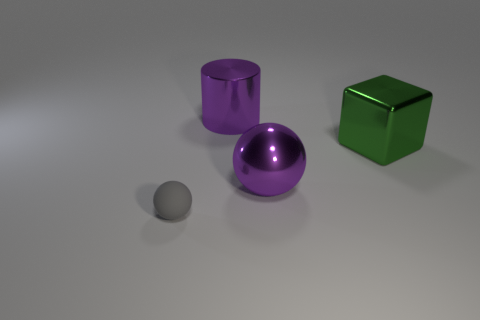Are there any other things that have the same material as the gray object?
Offer a very short reply. No. What is the gray thing made of?
Your answer should be compact. Rubber. How many other things are made of the same material as the large green thing?
Offer a terse response. 2. What number of spheres are in front of the large sphere and on the right side of the matte sphere?
Keep it short and to the point. 0. Is there a small brown thing of the same shape as the gray rubber thing?
Keep it short and to the point. No. There is a purple thing that is the same size as the purple metallic cylinder; what is its shape?
Your answer should be compact. Sphere. Are there the same number of purple metallic cylinders that are to the right of the large shiny cylinder and large shiny blocks behind the large green metallic thing?
Make the answer very short. Yes. What is the size of the purple object behind the large purple shiny object in front of the large green metallic block?
Offer a terse response. Large. Are there any metallic cylinders that have the same size as the cube?
Provide a succinct answer. Yes. There is a big sphere that is the same material as the cylinder; what color is it?
Your answer should be very brief. Purple. 